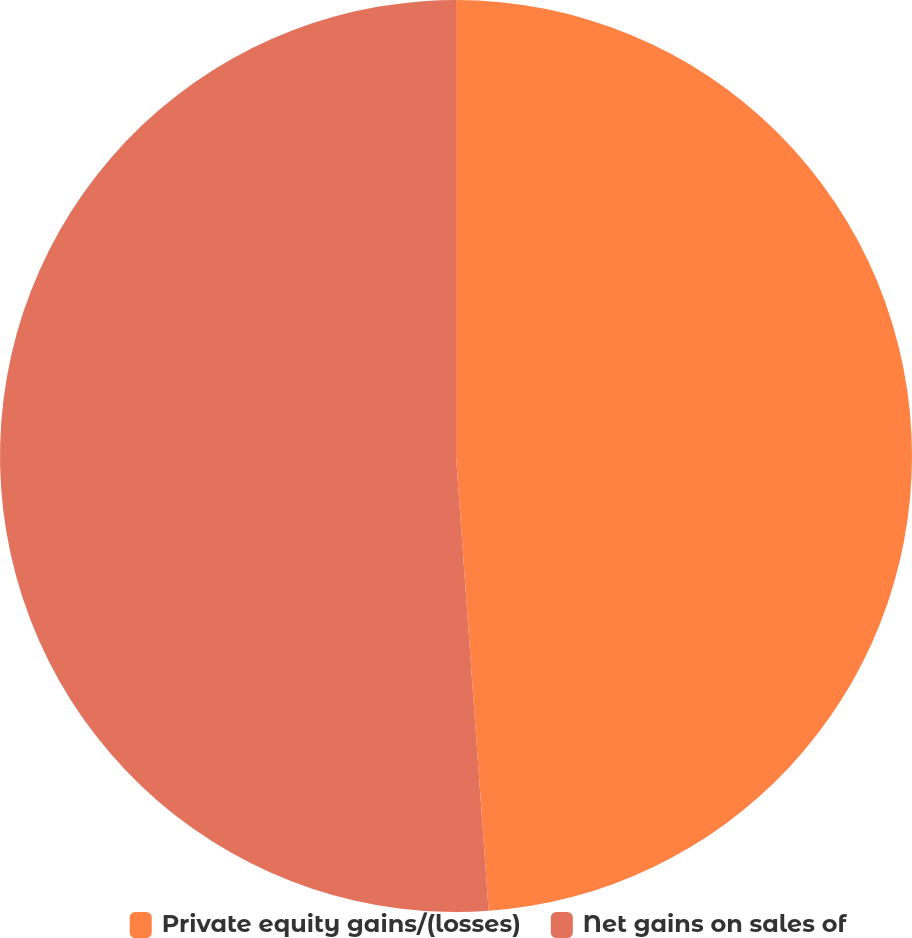<chart> <loc_0><loc_0><loc_500><loc_500><pie_chart><fcel>Private equity gains/(losses)<fcel>Net gains on sales of<nl><fcel>48.86%<fcel>51.14%<nl></chart> 